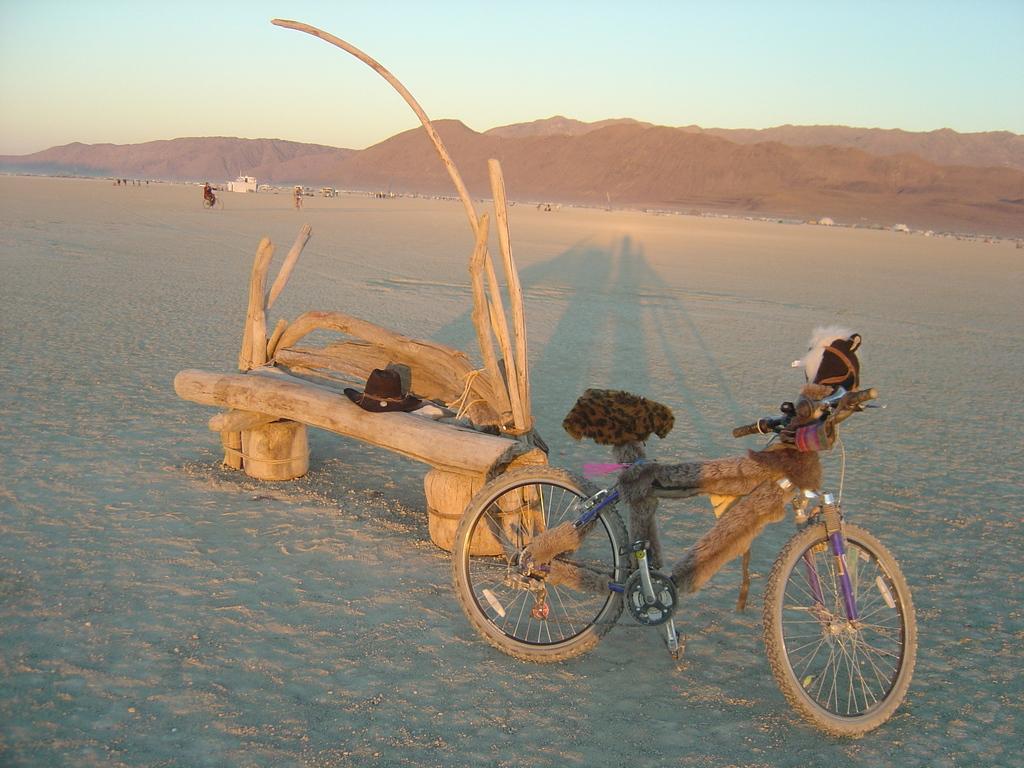Please provide a concise description of this image. In this image we can see a bicycle on the ground, some wooden poles and a hat on a bench. On the backside we can see a group of people, some buildings, the mountains and the sky which looks cloudy. 